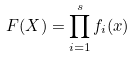<formula> <loc_0><loc_0><loc_500><loc_500>F ( X ) = \prod _ { i = 1 } ^ { s } f _ { i } ( x )</formula> 